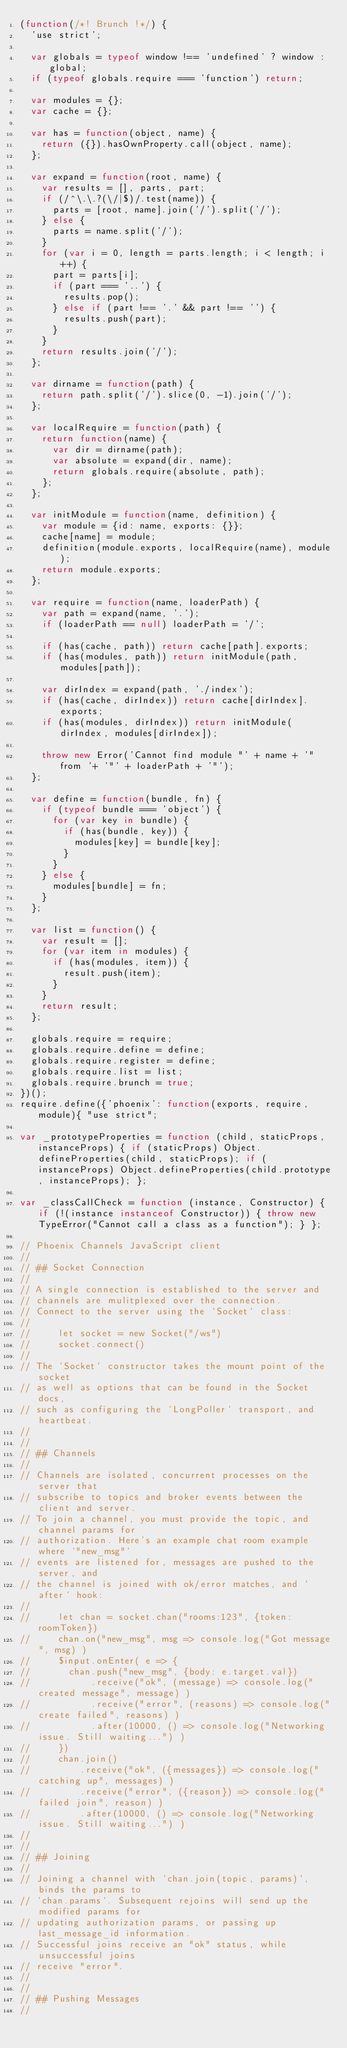<code> <loc_0><loc_0><loc_500><loc_500><_JavaScript_>(function(/*! Brunch !*/) {
  'use strict';

  var globals = typeof window !== 'undefined' ? window : global;
  if (typeof globals.require === 'function') return;

  var modules = {};
  var cache = {};

  var has = function(object, name) {
    return ({}).hasOwnProperty.call(object, name);
  };

  var expand = function(root, name) {
    var results = [], parts, part;
    if (/^\.\.?(\/|$)/.test(name)) {
      parts = [root, name].join('/').split('/');
    } else {
      parts = name.split('/');
    }
    for (var i = 0, length = parts.length; i < length; i++) {
      part = parts[i];
      if (part === '..') {
        results.pop();
      } else if (part !== '.' && part !== '') {
        results.push(part);
      }
    }
    return results.join('/');
  };

  var dirname = function(path) {
    return path.split('/').slice(0, -1).join('/');
  };

  var localRequire = function(path) {
    return function(name) {
      var dir = dirname(path);
      var absolute = expand(dir, name);
      return globals.require(absolute, path);
    };
  };

  var initModule = function(name, definition) {
    var module = {id: name, exports: {}};
    cache[name] = module;
    definition(module.exports, localRequire(name), module);
    return module.exports;
  };

  var require = function(name, loaderPath) {
    var path = expand(name, '.');
    if (loaderPath == null) loaderPath = '/';

    if (has(cache, path)) return cache[path].exports;
    if (has(modules, path)) return initModule(path, modules[path]);

    var dirIndex = expand(path, './index');
    if (has(cache, dirIndex)) return cache[dirIndex].exports;
    if (has(modules, dirIndex)) return initModule(dirIndex, modules[dirIndex]);

    throw new Error('Cannot find module "' + name + '" from '+ '"' + loaderPath + '"');
  };

  var define = function(bundle, fn) {
    if (typeof bundle === 'object') {
      for (var key in bundle) {
        if (has(bundle, key)) {
          modules[key] = bundle[key];
        }
      }
    } else {
      modules[bundle] = fn;
    }
  };

  var list = function() {
    var result = [];
    for (var item in modules) {
      if (has(modules, item)) {
        result.push(item);
      }
    }
    return result;
  };

  globals.require = require;
  globals.require.define = define;
  globals.require.register = define;
  globals.require.list = list;
  globals.require.brunch = true;
})();
require.define({'phoenix': function(exports, require, module){ "use strict";

var _prototypeProperties = function (child, staticProps, instanceProps) { if (staticProps) Object.defineProperties(child, staticProps); if (instanceProps) Object.defineProperties(child.prototype, instanceProps); };

var _classCallCheck = function (instance, Constructor) { if (!(instance instanceof Constructor)) { throw new TypeError("Cannot call a class as a function"); } };

// Phoenix Channels JavaScript client
//
// ## Socket Connection
//
// A single connection is established to the server and
// channels are mulitplexed over the connection.
// Connect to the server using the `Socket` class:
//
//     let socket = new Socket("/ws")
//     socket.connect()
//
// The `Socket` constructor takes the mount point of the socket
// as well as options that can be found in the Socket docs,
// such as configuring the `LongPoller` transport, and heartbeat.
//
//
// ## Channels
//
// Channels are isolated, concurrent processes on the server that
// subscribe to topics and broker events between the client and server.
// To join a channel, you must provide the topic, and channel params for
// authorization. Here's an example chat room example where `"new_msg"`
// events are listened for, messages are pushed to the server, and
// the channel is joined with ok/error matches, and `after` hook:
//
//     let chan = socket.chan("rooms:123", {token: roomToken})
//     chan.on("new_msg", msg => console.log("Got message", msg) )
//     $input.onEnter( e => {
//       chan.push("new_msg", {body: e.target.val})
//           .receive("ok", (message) => console.log("created message", message) )
//           .receive("error", (reasons) => console.log("create failed", reasons) )
//           .after(10000, () => console.log("Networking issue. Still waiting...") )
//     })
//     chan.join()
//         .receive("ok", ({messages}) => console.log("catching up", messages) )
//         .receive("error", ({reason}) => console.log("failed join", reason) )
//         .after(10000, () => console.log("Networking issue. Still waiting...") )
//
//
// ## Joining
//
// Joining a channel with `chan.join(topic, params)`, binds the params to
// `chan.params`. Subsequent rejoins will send up the modified params for
// updating authorization params, or passing up last_message_id information.
// Successful joins receive an "ok" status, while unsuccessful joins
// receive "error".
//
//
// ## Pushing Messages
//</code> 